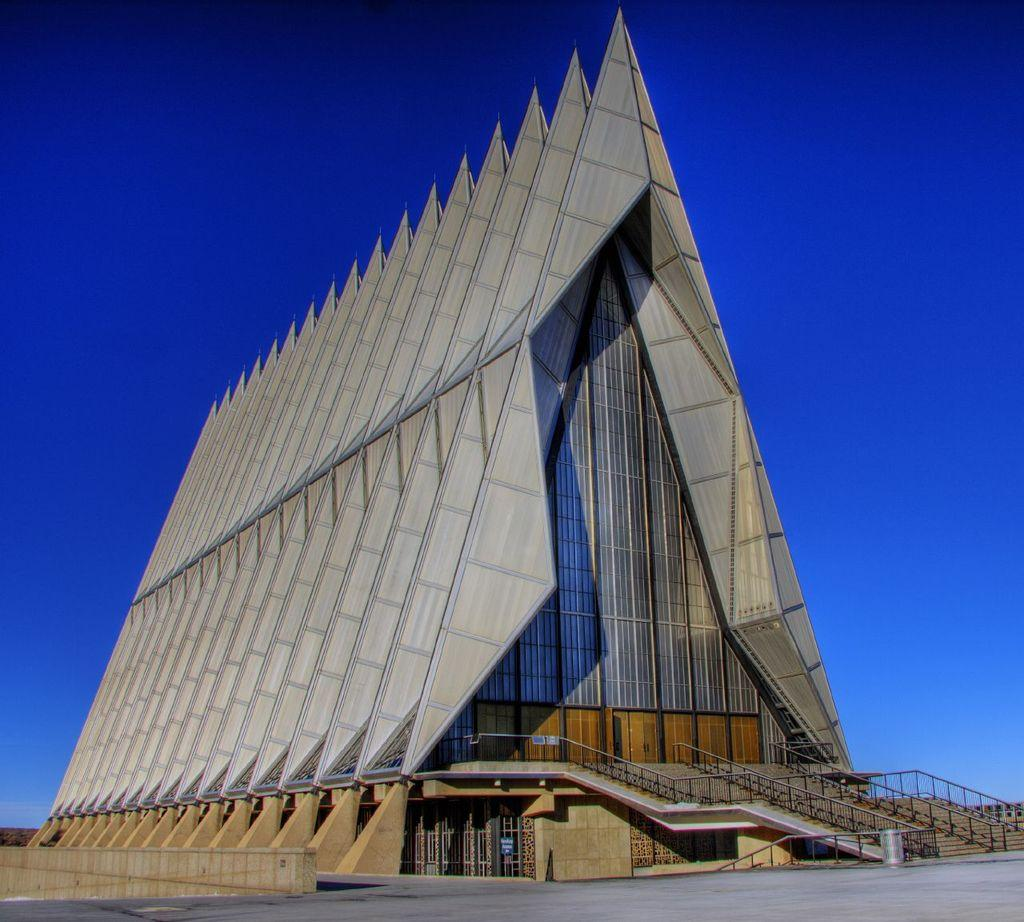What type of structures can be seen in the image? There is architecture in the image. What is visible at the top of the image? The sky is visible at the top of the image and appears to be clear. Where is the stove located in the image? There is no stove present in the image. What type of crib is visible in the image? There is no crib present in the image. 